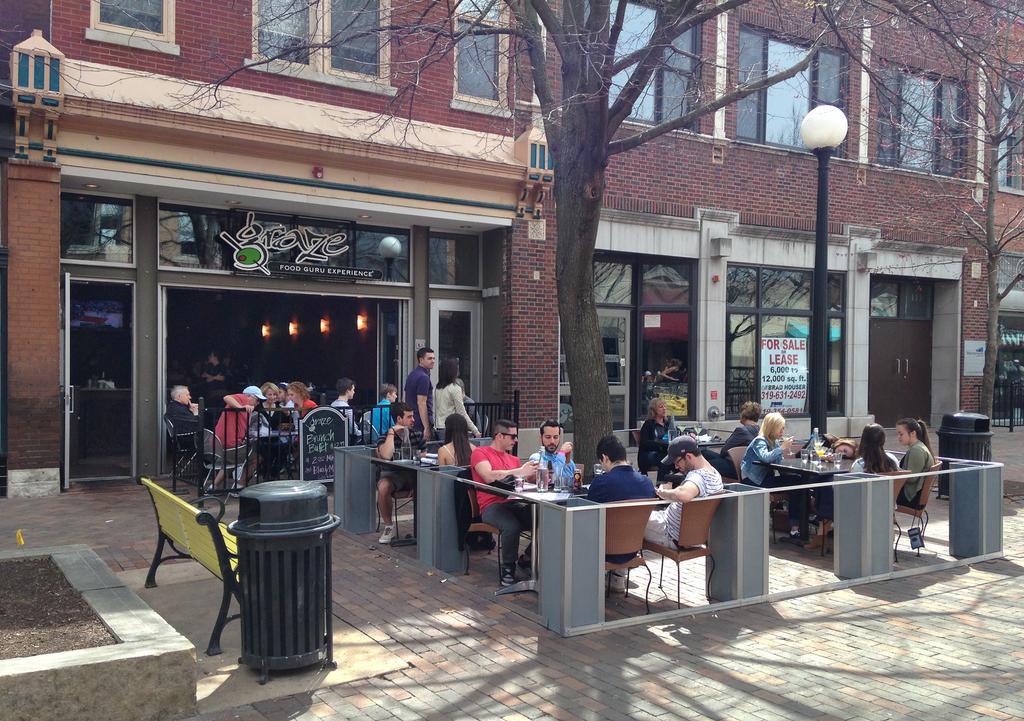Describe this image in one or two sentences. The picture is clicked outside and there are many people sitting on the table and food eatables on top of it. We observe a big tree between them. In the background we observe a restaurant which is named as grace food. 